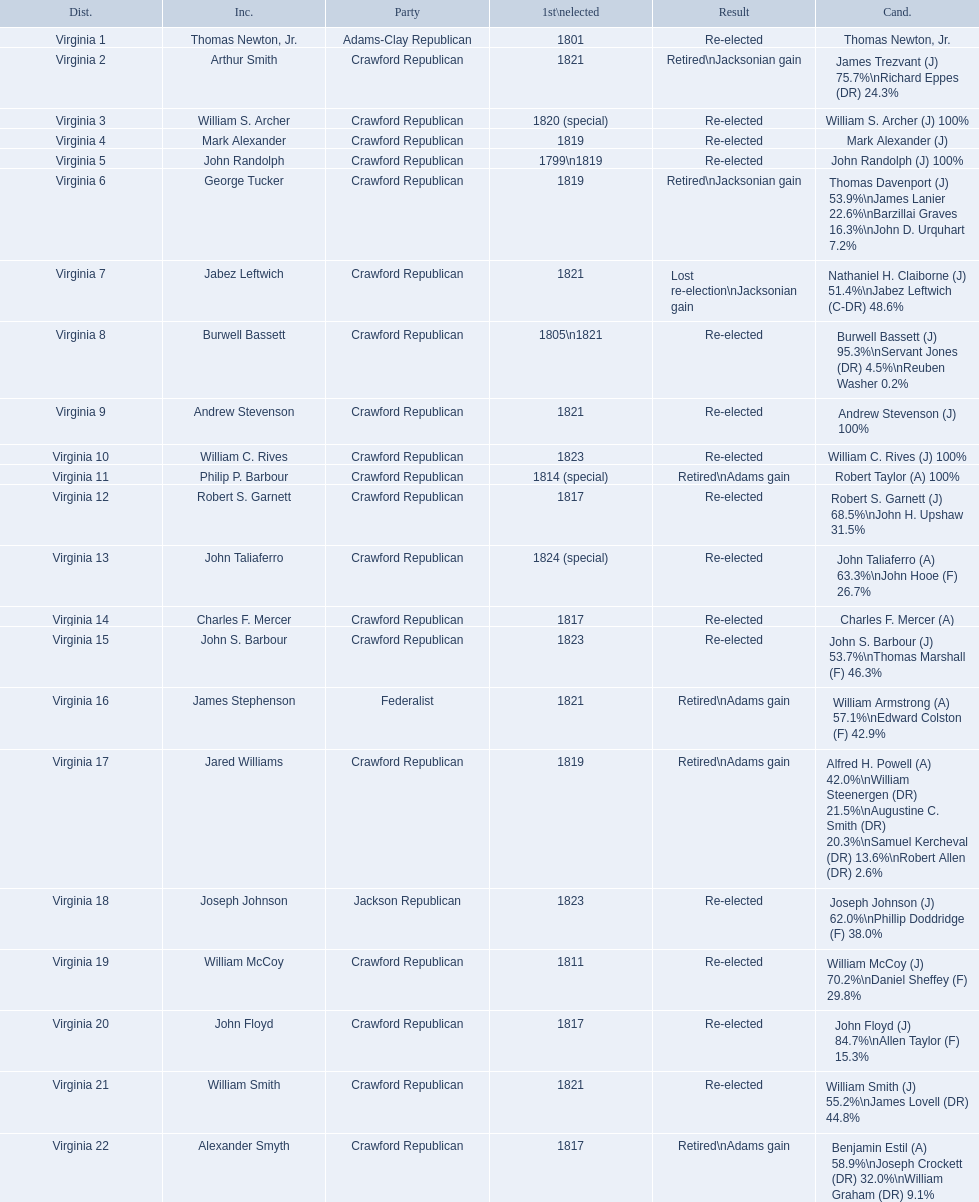Who were the incumbents of the 1824 united states house of representatives elections? Thomas Newton, Jr., Arthur Smith, William S. Archer, Mark Alexander, John Randolph, George Tucker, Jabez Leftwich, Burwell Bassett, Andrew Stevenson, William C. Rives, Philip P. Barbour, Robert S. Garnett, John Taliaferro, Charles F. Mercer, John S. Barbour, James Stephenson, Jared Williams, Joseph Johnson, William McCoy, John Floyd, William Smith, Alexander Smyth. And who were the candidates? Thomas Newton, Jr., James Trezvant (J) 75.7%\nRichard Eppes (DR) 24.3%, William S. Archer (J) 100%, Mark Alexander (J), John Randolph (J) 100%, Thomas Davenport (J) 53.9%\nJames Lanier 22.6%\nBarzillai Graves 16.3%\nJohn D. Urquhart 7.2%, Nathaniel H. Claiborne (J) 51.4%\nJabez Leftwich (C-DR) 48.6%, Burwell Bassett (J) 95.3%\nServant Jones (DR) 4.5%\nReuben Washer 0.2%, Andrew Stevenson (J) 100%, William C. Rives (J) 100%, Robert Taylor (A) 100%, Robert S. Garnett (J) 68.5%\nJohn H. Upshaw 31.5%, John Taliaferro (A) 63.3%\nJohn Hooe (F) 26.7%, Charles F. Mercer (A), John S. Barbour (J) 53.7%\nThomas Marshall (F) 46.3%, William Armstrong (A) 57.1%\nEdward Colston (F) 42.9%, Alfred H. Powell (A) 42.0%\nWilliam Steenergen (DR) 21.5%\nAugustine C. Smith (DR) 20.3%\nSamuel Kercheval (DR) 13.6%\nRobert Allen (DR) 2.6%, Joseph Johnson (J) 62.0%\nPhillip Doddridge (F) 38.0%, William McCoy (J) 70.2%\nDaniel Sheffey (F) 29.8%, John Floyd (J) 84.7%\nAllen Taylor (F) 15.3%, William Smith (J) 55.2%\nJames Lovell (DR) 44.8%, Benjamin Estil (A) 58.9%\nJoseph Crockett (DR) 32.0%\nWilliam Graham (DR) 9.1%. What were the results of their elections? Re-elected, Retired\nJacksonian gain, Re-elected, Re-elected, Re-elected, Retired\nJacksonian gain, Lost re-election\nJacksonian gain, Re-elected, Re-elected, Re-elected, Retired\nAdams gain, Re-elected, Re-elected, Re-elected, Re-elected, Retired\nAdams gain, Retired\nAdams gain, Re-elected, Re-elected, Re-elected, Re-elected, Retired\nAdams gain. And which jacksonian won over 76%? Arthur Smith. 